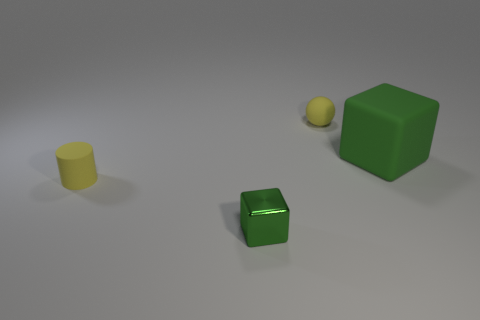What is the shape of the small object that is made of the same material as the tiny yellow cylinder?
Provide a succinct answer. Sphere. There is a object that is on the right side of the yellow rubber ball; is its size the same as the small metal thing?
Your response must be concise. No. What is the shape of the tiny yellow matte thing that is on the left side of the yellow object behind the large green matte cube?
Keep it short and to the point. Cylinder. There is a yellow object to the right of the small thing that is left of the small green shiny block; how big is it?
Provide a short and direct response. Small. What is the color of the small object on the left side of the tiny green metal object?
Provide a succinct answer. Yellow. The cylinder that is made of the same material as the small ball is what size?
Offer a terse response. Small. What number of other green objects are the same shape as the tiny green metallic thing?
Offer a very short reply. 1. What is the material of the ball that is the same size as the shiny thing?
Your response must be concise. Rubber. Is there a small green cube made of the same material as the small yellow ball?
Give a very brief answer. No. There is a tiny object that is behind the tiny green metallic cube and to the right of the small yellow cylinder; what color is it?
Make the answer very short. Yellow. 